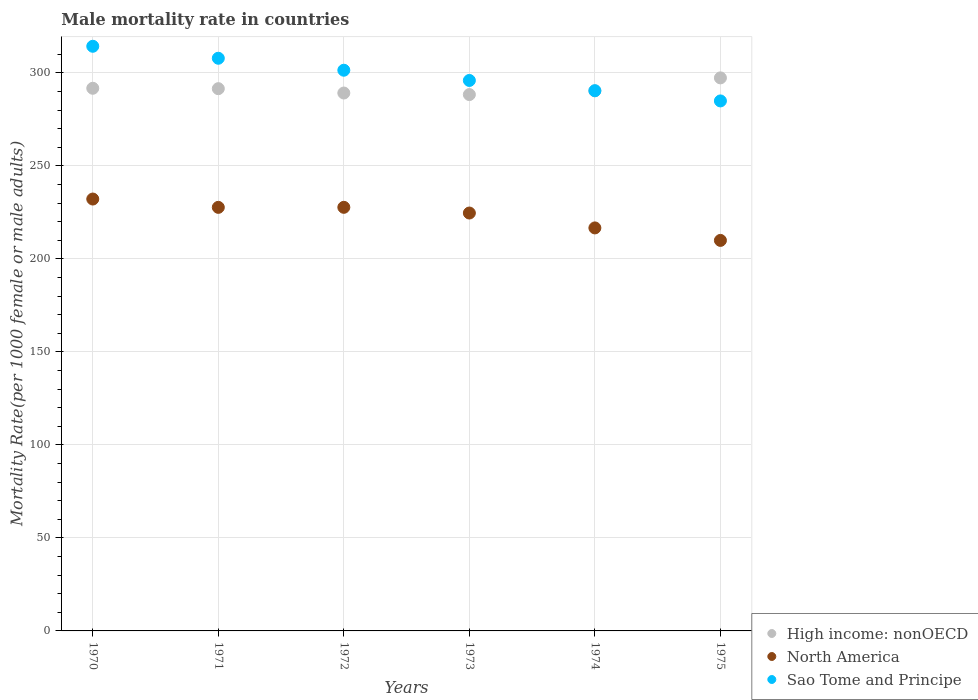How many different coloured dotlines are there?
Make the answer very short. 3. Is the number of dotlines equal to the number of legend labels?
Provide a succinct answer. Yes. What is the male mortality rate in Sao Tome and Principe in 1971?
Keep it short and to the point. 307.91. Across all years, what is the maximum male mortality rate in North America?
Your answer should be very brief. 232.21. Across all years, what is the minimum male mortality rate in Sao Tome and Principe?
Offer a very short reply. 284.97. In which year was the male mortality rate in High income: nonOECD maximum?
Your answer should be very brief. 1975. In which year was the male mortality rate in Sao Tome and Principe minimum?
Offer a terse response. 1975. What is the total male mortality rate in High income: nonOECD in the graph?
Ensure brevity in your answer.  1748.66. What is the difference between the male mortality rate in Sao Tome and Principe in 1972 and that in 1973?
Make the answer very short. 5.5. What is the difference between the male mortality rate in Sao Tome and Principe in 1971 and the male mortality rate in High income: nonOECD in 1974?
Give a very brief answer. 17.53. What is the average male mortality rate in Sao Tome and Principe per year?
Ensure brevity in your answer.  299.19. In the year 1970, what is the difference between the male mortality rate in Sao Tome and Principe and male mortality rate in High income: nonOECD?
Make the answer very short. 22.58. In how many years, is the male mortality rate in Sao Tome and Principe greater than 280?
Offer a terse response. 6. What is the ratio of the male mortality rate in North America in 1970 to that in 1971?
Provide a short and direct response. 1.02. Is the male mortality rate in High income: nonOECD in 1970 less than that in 1975?
Your answer should be compact. Yes. What is the difference between the highest and the second highest male mortality rate in High income: nonOECD?
Offer a terse response. 5.59. What is the difference between the highest and the lowest male mortality rate in North America?
Ensure brevity in your answer.  22.24. In how many years, is the male mortality rate in North America greater than the average male mortality rate in North America taken over all years?
Your answer should be compact. 4. Is the sum of the male mortality rate in High income: nonOECD in 1971 and 1974 greater than the maximum male mortality rate in North America across all years?
Your answer should be very brief. Yes. Does the male mortality rate in High income: nonOECD monotonically increase over the years?
Offer a terse response. No. Is the male mortality rate in High income: nonOECD strictly less than the male mortality rate in Sao Tome and Principe over the years?
Give a very brief answer. No. Does the graph contain grids?
Your response must be concise. Yes. How many legend labels are there?
Offer a terse response. 3. What is the title of the graph?
Your answer should be compact. Male mortality rate in countries. What is the label or title of the X-axis?
Offer a terse response. Years. What is the label or title of the Y-axis?
Keep it short and to the point. Mortality Rate(per 1000 female or male adults). What is the Mortality Rate(per 1000 female or male adults) of High income: nonOECD in 1970?
Your answer should be very brief. 291.77. What is the Mortality Rate(per 1000 female or male adults) in North America in 1970?
Offer a terse response. 232.21. What is the Mortality Rate(per 1000 female or male adults) in Sao Tome and Principe in 1970?
Your answer should be compact. 314.35. What is the Mortality Rate(per 1000 female or male adults) of High income: nonOECD in 1971?
Provide a succinct answer. 291.56. What is the Mortality Rate(per 1000 female or male adults) in North America in 1971?
Offer a terse response. 227.74. What is the Mortality Rate(per 1000 female or male adults) of Sao Tome and Principe in 1971?
Your answer should be very brief. 307.91. What is the Mortality Rate(per 1000 female or male adults) in High income: nonOECD in 1972?
Offer a terse response. 289.22. What is the Mortality Rate(per 1000 female or male adults) in North America in 1972?
Ensure brevity in your answer.  227.76. What is the Mortality Rate(per 1000 female or male adults) in Sao Tome and Principe in 1972?
Make the answer very short. 301.48. What is the Mortality Rate(per 1000 female or male adults) in High income: nonOECD in 1973?
Provide a succinct answer. 288.38. What is the Mortality Rate(per 1000 female or male adults) in North America in 1973?
Your answer should be very brief. 224.69. What is the Mortality Rate(per 1000 female or male adults) of Sao Tome and Principe in 1973?
Give a very brief answer. 295.97. What is the Mortality Rate(per 1000 female or male adults) in High income: nonOECD in 1974?
Offer a terse response. 290.38. What is the Mortality Rate(per 1000 female or male adults) of North America in 1974?
Your response must be concise. 216.69. What is the Mortality Rate(per 1000 female or male adults) of Sao Tome and Principe in 1974?
Keep it short and to the point. 290.47. What is the Mortality Rate(per 1000 female or male adults) in High income: nonOECD in 1975?
Keep it short and to the point. 297.35. What is the Mortality Rate(per 1000 female or male adults) of North America in 1975?
Make the answer very short. 209.97. What is the Mortality Rate(per 1000 female or male adults) in Sao Tome and Principe in 1975?
Ensure brevity in your answer.  284.97. Across all years, what is the maximum Mortality Rate(per 1000 female or male adults) of High income: nonOECD?
Provide a short and direct response. 297.35. Across all years, what is the maximum Mortality Rate(per 1000 female or male adults) of North America?
Keep it short and to the point. 232.21. Across all years, what is the maximum Mortality Rate(per 1000 female or male adults) in Sao Tome and Principe?
Make the answer very short. 314.35. Across all years, what is the minimum Mortality Rate(per 1000 female or male adults) of High income: nonOECD?
Keep it short and to the point. 288.38. Across all years, what is the minimum Mortality Rate(per 1000 female or male adults) in North America?
Keep it short and to the point. 209.97. Across all years, what is the minimum Mortality Rate(per 1000 female or male adults) of Sao Tome and Principe?
Provide a short and direct response. 284.97. What is the total Mortality Rate(per 1000 female or male adults) in High income: nonOECD in the graph?
Provide a short and direct response. 1748.66. What is the total Mortality Rate(per 1000 female or male adults) in North America in the graph?
Your answer should be very brief. 1339.06. What is the total Mortality Rate(per 1000 female or male adults) of Sao Tome and Principe in the graph?
Your answer should be very brief. 1795.14. What is the difference between the Mortality Rate(per 1000 female or male adults) of High income: nonOECD in 1970 and that in 1971?
Provide a short and direct response. 0.21. What is the difference between the Mortality Rate(per 1000 female or male adults) in North America in 1970 and that in 1971?
Provide a short and direct response. 4.47. What is the difference between the Mortality Rate(per 1000 female or male adults) in Sao Tome and Principe in 1970 and that in 1971?
Your answer should be very brief. 6.44. What is the difference between the Mortality Rate(per 1000 female or male adults) of High income: nonOECD in 1970 and that in 1972?
Keep it short and to the point. 2.55. What is the difference between the Mortality Rate(per 1000 female or male adults) of North America in 1970 and that in 1972?
Give a very brief answer. 4.46. What is the difference between the Mortality Rate(per 1000 female or male adults) of Sao Tome and Principe in 1970 and that in 1972?
Give a very brief answer. 12.87. What is the difference between the Mortality Rate(per 1000 female or male adults) in High income: nonOECD in 1970 and that in 1973?
Your answer should be compact. 3.38. What is the difference between the Mortality Rate(per 1000 female or male adults) in North America in 1970 and that in 1973?
Give a very brief answer. 7.52. What is the difference between the Mortality Rate(per 1000 female or male adults) of Sao Tome and Principe in 1970 and that in 1973?
Offer a very short reply. 18.38. What is the difference between the Mortality Rate(per 1000 female or male adults) of High income: nonOECD in 1970 and that in 1974?
Your answer should be very brief. 1.38. What is the difference between the Mortality Rate(per 1000 female or male adults) of North America in 1970 and that in 1974?
Keep it short and to the point. 15.53. What is the difference between the Mortality Rate(per 1000 female or male adults) of Sao Tome and Principe in 1970 and that in 1974?
Offer a terse response. 23.88. What is the difference between the Mortality Rate(per 1000 female or male adults) of High income: nonOECD in 1970 and that in 1975?
Offer a terse response. -5.59. What is the difference between the Mortality Rate(per 1000 female or male adults) of North America in 1970 and that in 1975?
Your response must be concise. 22.24. What is the difference between the Mortality Rate(per 1000 female or male adults) in Sao Tome and Principe in 1970 and that in 1975?
Provide a succinct answer. 29.38. What is the difference between the Mortality Rate(per 1000 female or male adults) of High income: nonOECD in 1971 and that in 1972?
Offer a terse response. 2.34. What is the difference between the Mortality Rate(per 1000 female or male adults) in North America in 1971 and that in 1972?
Your answer should be very brief. -0.02. What is the difference between the Mortality Rate(per 1000 female or male adults) in Sao Tome and Principe in 1971 and that in 1972?
Provide a short and direct response. 6.44. What is the difference between the Mortality Rate(per 1000 female or male adults) in High income: nonOECD in 1971 and that in 1973?
Provide a succinct answer. 3.17. What is the difference between the Mortality Rate(per 1000 female or male adults) of North America in 1971 and that in 1973?
Offer a terse response. 3.05. What is the difference between the Mortality Rate(per 1000 female or male adults) in Sao Tome and Principe in 1971 and that in 1973?
Ensure brevity in your answer.  11.94. What is the difference between the Mortality Rate(per 1000 female or male adults) of High income: nonOECD in 1971 and that in 1974?
Your answer should be very brief. 1.17. What is the difference between the Mortality Rate(per 1000 female or male adults) in North America in 1971 and that in 1974?
Your answer should be very brief. 11.05. What is the difference between the Mortality Rate(per 1000 female or male adults) of Sao Tome and Principe in 1971 and that in 1974?
Your answer should be compact. 17.44. What is the difference between the Mortality Rate(per 1000 female or male adults) of High income: nonOECD in 1971 and that in 1975?
Keep it short and to the point. -5.8. What is the difference between the Mortality Rate(per 1000 female or male adults) of North America in 1971 and that in 1975?
Ensure brevity in your answer.  17.77. What is the difference between the Mortality Rate(per 1000 female or male adults) in Sao Tome and Principe in 1971 and that in 1975?
Your answer should be compact. 22.95. What is the difference between the Mortality Rate(per 1000 female or male adults) of High income: nonOECD in 1972 and that in 1973?
Your answer should be compact. 0.83. What is the difference between the Mortality Rate(per 1000 female or male adults) of North America in 1972 and that in 1973?
Provide a succinct answer. 3.07. What is the difference between the Mortality Rate(per 1000 female or male adults) in Sao Tome and Principe in 1972 and that in 1973?
Provide a succinct answer. 5.5. What is the difference between the Mortality Rate(per 1000 female or male adults) of High income: nonOECD in 1972 and that in 1974?
Your response must be concise. -1.17. What is the difference between the Mortality Rate(per 1000 female or male adults) in North America in 1972 and that in 1974?
Give a very brief answer. 11.07. What is the difference between the Mortality Rate(per 1000 female or male adults) of Sao Tome and Principe in 1972 and that in 1974?
Your answer should be very brief. 11.01. What is the difference between the Mortality Rate(per 1000 female or male adults) in High income: nonOECD in 1972 and that in 1975?
Make the answer very short. -8.14. What is the difference between the Mortality Rate(per 1000 female or male adults) in North America in 1972 and that in 1975?
Provide a short and direct response. 17.79. What is the difference between the Mortality Rate(per 1000 female or male adults) of Sao Tome and Principe in 1972 and that in 1975?
Provide a short and direct response. 16.51. What is the difference between the Mortality Rate(per 1000 female or male adults) in High income: nonOECD in 1973 and that in 1974?
Your answer should be very brief. -2. What is the difference between the Mortality Rate(per 1000 female or male adults) of North America in 1973 and that in 1974?
Make the answer very short. 8.01. What is the difference between the Mortality Rate(per 1000 female or male adults) in Sao Tome and Principe in 1973 and that in 1974?
Provide a short and direct response. 5.5. What is the difference between the Mortality Rate(per 1000 female or male adults) in High income: nonOECD in 1973 and that in 1975?
Your answer should be very brief. -8.97. What is the difference between the Mortality Rate(per 1000 female or male adults) in North America in 1973 and that in 1975?
Your answer should be very brief. 14.72. What is the difference between the Mortality Rate(per 1000 female or male adults) in Sao Tome and Principe in 1973 and that in 1975?
Your response must be concise. 11.01. What is the difference between the Mortality Rate(per 1000 female or male adults) in High income: nonOECD in 1974 and that in 1975?
Your answer should be compact. -6.97. What is the difference between the Mortality Rate(per 1000 female or male adults) of North America in 1974 and that in 1975?
Give a very brief answer. 6.71. What is the difference between the Mortality Rate(per 1000 female or male adults) in Sao Tome and Principe in 1974 and that in 1975?
Keep it short and to the point. 5.5. What is the difference between the Mortality Rate(per 1000 female or male adults) in High income: nonOECD in 1970 and the Mortality Rate(per 1000 female or male adults) in North America in 1971?
Keep it short and to the point. 64.03. What is the difference between the Mortality Rate(per 1000 female or male adults) of High income: nonOECD in 1970 and the Mortality Rate(per 1000 female or male adults) of Sao Tome and Principe in 1971?
Offer a terse response. -16.14. What is the difference between the Mortality Rate(per 1000 female or male adults) in North America in 1970 and the Mortality Rate(per 1000 female or male adults) in Sao Tome and Principe in 1971?
Your answer should be compact. -75.7. What is the difference between the Mortality Rate(per 1000 female or male adults) in High income: nonOECD in 1970 and the Mortality Rate(per 1000 female or male adults) in North America in 1972?
Offer a terse response. 64.01. What is the difference between the Mortality Rate(per 1000 female or male adults) of High income: nonOECD in 1970 and the Mortality Rate(per 1000 female or male adults) of Sao Tome and Principe in 1972?
Make the answer very short. -9.71. What is the difference between the Mortality Rate(per 1000 female or male adults) in North America in 1970 and the Mortality Rate(per 1000 female or male adults) in Sao Tome and Principe in 1972?
Ensure brevity in your answer.  -69.26. What is the difference between the Mortality Rate(per 1000 female or male adults) in High income: nonOECD in 1970 and the Mortality Rate(per 1000 female or male adults) in North America in 1973?
Provide a short and direct response. 67.08. What is the difference between the Mortality Rate(per 1000 female or male adults) of High income: nonOECD in 1970 and the Mortality Rate(per 1000 female or male adults) of Sao Tome and Principe in 1973?
Offer a very short reply. -4.21. What is the difference between the Mortality Rate(per 1000 female or male adults) of North America in 1970 and the Mortality Rate(per 1000 female or male adults) of Sao Tome and Principe in 1973?
Provide a short and direct response. -63.76. What is the difference between the Mortality Rate(per 1000 female or male adults) of High income: nonOECD in 1970 and the Mortality Rate(per 1000 female or male adults) of North America in 1974?
Keep it short and to the point. 75.08. What is the difference between the Mortality Rate(per 1000 female or male adults) of High income: nonOECD in 1970 and the Mortality Rate(per 1000 female or male adults) of Sao Tome and Principe in 1974?
Offer a very short reply. 1.3. What is the difference between the Mortality Rate(per 1000 female or male adults) of North America in 1970 and the Mortality Rate(per 1000 female or male adults) of Sao Tome and Principe in 1974?
Offer a very short reply. -58.25. What is the difference between the Mortality Rate(per 1000 female or male adults) of High income: nonOECD in 1970 and the Mortality Rate(per 1000 female or male adults) of North America in 1975?
Provide a succinct answer. 81.79. What is the difference between the Mortality Rate(per 1000 female or male adults) of High income: nonOECD in 1970 and the Mortality Rate(per 1000 female or male adults) of Sao Tome and Principe in 1975?
Your answer should be compact. 6.8. What is the difference between the Mortality Rate(per 1000 female or male adults) in North America in 1970 and the Mortality Rate(per 1000 female or male adults) in Sao Tome and Principe in 1975?
Offer a terse response. -52.75. What is the difference between the Mortality Rate(per 1000 female or male adults) in High income: nonOECD in 1971 and the Mortality Rate(per 1000 female or male adults) in North America in 1972?
Provide a short and direct response. 63.8. What is the difference between the Mortality Rate(per 1000 female or male adults) of High income: nonOECD in 1971 and the Mortality Rate(per 1000 female or male adults) of Sao Tome and Principe in 1972?
Provide a short and direct response. -9.92. What is the difference between the Mortality Rate(per 1000 female or male adults) of North America in 1971 and the Mortality Rate(per 1000 female or male adults) of Sao Tome and Principe in 1972?
Provide a succinct answer. -73.74. What is the difference between the Mortality Rate(per 1000 female or male adults) in High income: nonOECD in 1971 and the Mortality Rate(per 1000 female or male adults) in North America in 1973?
Offer a very short reply. 66.87. What is the difference between the Mortality Rate(per 1000 female or male adults) of High income: nonOECD in 1971 and the Mortality Rate(per 1000 female or male adults) of Sao Tome and Principe in 1973?
Offer a terse response. -4.41. What is the difference between the Mortality Rate(per 1000 female or male adults) in North America in 1971 and the Mortality Rate(per 1000 female or male adults) in Sao Tome and Principe in 1973?
Provide a short and direct response. -68.23. What is the difference between the Mortality Rate(per 1000 female or male adults) in High income: nonOECD in 1971 and the Mortality Rate(per 1000 female or male adults) in North America in 1974?
Keep it short and to the point. 74.87. What is the difference between the Mortality Rate(per 1000 female or male adults) of High income: nonOECD in 1971 and the Mortality Rate(per 1000 female or male adults) of Sao Tome and Principe in 1974?
Make the answer very short. 1.09. What is the difference between the Mortality Rate(per 1000 female or male adults) in North America in 1971 and the Mortality Rate(per 1000 female or male adults) in Sao Tome and Principe in 1974?
Give a very brief answer. -62.73. What is the difference between the Mortality Rate(per 1000 female or male adults) of High income: nonOECD in 1971 and the Mortality Rate(per 1000 female or male adults) of North America in 1975?
Keep it short and to the point. 81.58. What is the difference between the Mortality Rate(per 1000 female or male adults) in High income: nonOECD in 1971 and the Mortality Rate(per 1000 female or male adults) in Sao Tome and Principe in 1975?
Give a very brief answer. 6.59. What is the difference between the Mortality Rate(per 1000 female or male adults) of North America in 1971 and the Mortality Rate(per 1000 female or male adults) of Sao Tome and Principe in 1975?
Offer a very short reply. -57.23. What is the difference between the Mortality Rate(per 1000 female or male adults) in High income: nonOECD in 1972 and the Mortality Rate(per 1000 female or male adults) in North America in 1973?
Keep it short and to the point. 64.53. What is the difference between the Mortality Rate(per 1000 female or male adults) of High income: nonOECD in 1972 and the Mortality Rate(per 1000 female or male adults) of Sao Tome and Principe in 1973?
Your answer should be compact. -6.76. What is the difference between the Mortality Rate(per 1000 female or male adults) of North America in 1972 and the Mortality Rate(per 1000 female or male adults) of Sao Tome and Principe in 1973?
Your response must be concise. -68.21. What is the difference between the Mortality Rate(per 1000 female or male adults) of High income: nonOECD in 1972 and the Mortality Rate(per 1000 female or male adults) of North America in 1974?
Ensure brevity in your answer.  72.53. What is the difference between the Mortality Rate(per 1000 female or male adults) of High income: nonOECD in 1972 and the Mortality Rate(per 1000 female or male adults) of Sao Tome and Principe in 1974?
Provide a succinct answer. -1.25. What is the difference between the Mortality Rate(per 1000 female or male adults) of North America in 1972 and the Mortality Rate(per 1000 female or male adults) of Sao Tome and Principe in 1974?
Make the answer very short. -62.71. What is the difference between the Mortality Rate(per 1000 female or male adults) of High income: nonOECD in 1972 and the Mortality Rate(per 1000 female or male adults) of North America in 1975?
Your response must be concise. 79.24. What is the difference between the Mortality Rate(per 1000 female or male adults) in High income: nonOECD in 1972 and the Mortality Rate(per 1000 female or male adults) in Sao Tome and Principe in 1975?
Make the answer very short. 4.25. What is the difference between the Mortality Rate(per 1000 female or male adults) in North America in 1972 and the Mortality Rate(per 1000 female or male adults) in Sao Tome and Principe in 1975?
Offer a terse response. -57.21. What is the difference between the Mortality Rate(per 1000 female or male adults) of High income: nonOECD in 1973 and the Mortality Rate(per 1000 female or male adults) of North America in 1974?
Your response must be concise. 71.7. What is the difference between the Mortality Rate(per 1000 female or male adults) of High income: nonOECD in 1973 and the Mortality Rate(per 1000 female or male adults) of Sao Tome and Principe in 1974?
Provide a succinct answer. -2.09. What is the difference between the Mortality Rate(per 1000 female or male adults) in North America in 1973 and the Mortality Rate(per 1000 female or male adults) in Sao Tome and Principe in 1974?
Offer a terse response. -65.78. What is the difference between the Mortality Rate(per 1000 female or male adults) in High income: nonOECD in 1973 and the Mortality Rate(per 1000 female or male adults) in North America in 1975?
Provide a short and direct response. 78.41. What is the difference between the Mortality Rate(per 1000 female or male adults) of High income: nonOECD in 1973 and the Mortality Rate(per 1000 female or male adults) of Sao Tome and Principe in 1975?
Ensure brevity in your answer.  3.42. What is the difference between the Mortality Rate(per 1000 female or male adults) of North America in 1973 and the Mortality Rate(per 1000 female or male adults) of Sao Tome and Principe in 1975?
Keep it short and to the point. -60.28. What is the difference between the Mortality Rate(per 1000 female or male adults) of High income: nonOECD in 1974 and the Mortality Rate(per 1000 female or male adults) of North America in 1975?
Offer a terse response. 80.41. What is the difference between the Mortality Rate(per 1000 female or male adults) in High income: nonOECD in 1974 and the Mortality Rate(per 1000 female or male adults) in Sao Tome and Principe in 1975?
Offer a terse response. 5.42. What is the difference between the Mortality Rate(per 1000 female or male adults) in North America in 1974 and the Mortality Rate(per 1000 female or male adults) in Sao Tome and Principe in 1975?
Offer a very short reply. -68.28. What is the average Mortality Rate(per 1000 female or male adults) of High income: nonOECD per year?
Ensure brevity in your answer.  291.44. What is the average Mortality Rate(per 1000 female or male adults) in North America per year?
Keep it short and to the point. 223.18. What is the average Mortality Rate(per 1000 female or male adults) of Sao Tome and Principe per year?
Provide a short and direct response. 299.19. In the year 1970, what is the difference between the Mortality Rate(per 1000 female or male adults) of High income: nonOECD and Mortality Rate(per 1000 female or male adults) of North America?
Your response must be concise. 59.55. In the year 1970, what is the difference between the Mortality Rate(per 1000 female or male adults) of High income: nonOECD and Mortality Rate(per 1000 female or male adults) of Sao Tome and Principe?
Provide a short and direct response. -22.58. In the year 1970, what is the difference between the Mortality Rate(per 1000 female or male adults) of North America and Mortality Rate(per 1000 female or male adults) of Sao Tome and Principe?
Your response must be concise. -82.13. In the year 1971, what is the difference between the Mortality Rate(per 1000 female or male adults) in High income: nonOECD and Mortality Rate(per 1000 female or male adults) in North America?
Give a very brief answer. 63.82. In the year 1971, what is the difference between the Mortality Rate(per 1000 female or male adults) in High income: nonOECD and Mortality Rate(per 1000 female or male adults) in Sao Tome and Principe?
Offer a very short reply. -16.35. In the year 1971, what is the difference between the Mortality Rate(per 1000 female or male adults) of North America and Mortality Rate(per 1000 female or male adults) of Sao Tome and Principe?
Offer a terse response. -80.17. In the year 1972, what is the difference between the Mortality Rate(per 1000 female or male adults) of High income: nonOECD and Mortality Rate(per 1000 female or male adults) of North America?
Your answer should be compact. 61.46. In the year 1972, what is the difference between the Mortality Rate(per 1000 female or male adults) of High income: nonOECD and Mortality Rate(per 1000 female or male adults) of Sao Tome and Principe?
Give a very brief answer. -12.26. In the year 1972, what is the difference between the Mortality Rate(per 1000 female or male adults) in North America and Mortality Rate(per 1000 female or male adults) in Sao Tome and Principe?
Provide a short and direct response. -73.72. In the year 1973, what is the difference between the Mortality Rate(per 1000 female or male adults) of High income: nonOECD and Mortality Rate(per 1000 female or male adults) of North America?
Give a very brief answer. 63.69. In the year 1973, what is the difference between the Mortality Rate(per 1000 female or male adults) of High income: nonOECD and Mortality Rate(per 1000 female or male adults) of Sao Tome and Principe?
Keep it short and to the point. -7.59. In the year 1973, what is the difference between the Mortality Rate(per 1000 female or male adults) of North America and Mortality Rate(per 1000 female or male adults) of Sao Tome and Principe?
Offer a very short reply. -71.28. In the year 1974, what is the difference between the Mortality Rate(per 1000 female or male adults) of High income: nonOECD and Mortality Rate(per 1000 female or male adults) of North America?
Ensure brevity in your answer.  73.7. In the year 1974, what is the difference between the Mortality Rate(per 1000 female or male adults) in High income: nonOECD and Mortality Rate(per 1000 female or male adults) in Sao Tome and Principe?
Your response must be concise. -0.09. In the year 1974, what is the difference between the Mortality Rate(per 1000 female or male adults) of North America and Mortality Rate(per 1000 female or male adults) of Sao Tome and Principe?
Provide a short and direct response. -73.78. In the year 1975, what is the difference between the Mortality Rate(per 1000 female or male adults) of High income: nonOECD and Mortality Rate(per 1000 female or male adults) of North America?
Provide a short and direct response. 87.38. In the year 1975, what is the difference between the Mortality Rate(per 1000 female or male adults) in High income: nonOECD and Mortality Rate(per 1000 female or male adults) in Sao Tome and Principe?
Offer a very short reply. 12.39. In the year 1975, what is the difference between the Mortality Rate(per 1000 female or male adults) of North America and Mortality Rate(per 1000 female or male adults) of Sao Tome and Principe?
Provide a short and direct response. -74.99. What is the ratio of the Mortality Rate(per 1000 female or male adults) of North America in 1970 to that in 1971?
Your answer should be compact. 1.02. What is the ratio of the Mortality Rate(per 1000 female or male adults) of Sao Tome and Principe in 1970 to that in 1971?
Your answer should be compact. 1.02. What is the ratio of the Mortality Rate(per 1000 female or male adults) in High income: nonOECD in 1970 to that in 1972?
Your answer should be very brief. 1.01. What is the ratio of the Mortality Rate(per 1000 female or male adults) of North America in 1970 to that in 1972?
Your answer should be very brief. 1.02. What is the ratio of the Mortality Rate(per 1000 female or male adults) in Sao Tome and Principe in 1970 to that in 1972?
Provide a short and direct response. 1.04. What is the ratio of the Mortality Rate(per 1000 female or male adults) of High income: nonOECD in 1970 to that in 1973?
Ensure brevity in your answer.  1.01. What is the ratio of the Mortality Rate(per 1000 female or male adults) of North America in 1970 to that in 1973?
Your answer should be compact. 1.03. What is the ratio of the Mortality Rate(per 1000 female or male adults) of Sao Tome and Principe in 1970 to that in 1973?
Offer a terse response. 1.06. What is the ratio of the Mortality Rate(per 1000 female or male adults) of High income: nonOECD in 1970 to that in 1974?
Provide a succinct answer. 1. What is the ratio of the Mortality Rate(per 1000 female or male adults) in North America in 1970 to that in 1974?
Provide a short and direct response. 1.07. What is the ratio of the Mortality Rate(per 1000 female or male adults) of Sao Tome and Principe in 1970 to that in 1974?
Give a very brief answer. 1.08. What is the ratio of the Mortality Rate(per 1000 female or male adults) of High income: nonOECD in 1970 to that in 1975?
Ensure brevity in your answer.  0.98. What is the ratio of the Mortality Rate(per 1000 female or male adults) of North America in 1970 to that in 1975?
Keep it short and to the point. 1.11. What is the ratio of the Mortality Rate(per 1000 female or male adults) of Sao Tome and Principe in 1970 to that in 1975?
Your answer should be compact. 1.1. What is the ratio of the Mortality Rate(per 1000 female or male adults) of Sao Tome and Principe in 1971 to that in 1972?
Ensure brevity in your answer.  1.02. What is the ratio of the Mortality Rate(per 1000 female or male adults) in North America in 1971 to that in 1973?
Offer a terse response. 1.01. What is the ratio of the Mortality Rate(per 1000 female or male adults) of Sao Tome and Principe in 1971 to that in 1973?
Ensure brevity in your answer.  1.04. What is the ratio of the Mortality Rate(per 1000 female or male adults) in High income: nonOECD in 1971 to that in 1974?
Your answer should be compact. 1. What is the ratio of the Mortality Rate(per 1000 female or male adults) of North America in 1971 to that in 1974?
Make the answer very short. 1.05. What is the ratio of the Mortality Rate(per 1000 female or male adults) of Sao Tome and Principe in 1971 to that in 1974?
Provide a succinct answer. 1.06. What is the ratio of the Mortality Rate(per 1000 female or male adults) of High income: nonOECD in 1971 to that in 1975?
Offer a very short reply. 0.98. What is the ratio of the Mortality Rate(per 1000 female or male adults) in North America in 1971 to that in 1975?
Give a very brief answer. 1.08. What is the ratio of the Mortality Rate(per 1000 female or male adults) of Sao Tome and Principe in 1971 to that in 1975?
Your response must be concise. 1.08. What is the ratio of the Mortality Rate(per 1000 female or male adults) of North America in 1972 to that in 1973?
Offer a very short reply. 1.01. What is the ratio of the Mortality Rate(per 1000 female or male adults) in Sao Tome and Principe in 1972 to that in 1973?
Give a very brief answer. 1.02. What is the ratio of the Mortality Rate(per 1000 female or male adults) of North America in 1972 to that in 1974?
Offer a very short reply. 1.05. What is the ratio of the Mortality Rate(per 1000 female or male adults) in Sao Tome and Principe in 1972 to that in 1974?
Ensure brevity in your answer.  1.04. What is the ratio of the Mortality Rate(per 1000 female or male adults) of High income: nonOECD in 1972 to that in 1975?
Make the answer very short. 0.97. What is the ratio of the Mortality Rate(per 1000 female or male adults) in North America in 1972 to that in 1975?
Your answer should be compact. 1.08. What is the ratio of the Mortality Rate(per 1000 female or male adults) of Sao Tome and Principe in 1972 to that in 1975?
Provide a short and direct response. 1.06. What is the ratio of the Mortality Rate(per 1000 female or male adults) of High income: nonOECD in 1973 to that in 1974?
Provide a short and direct response. 0.99. What is the ratio of the Mortality Rate(per 1000 female or male adults) of North America in 1973 to that in 1974?
Your answer should be compact. 1.04. What is the ratio of the Mortality Rate(per 1000 female or male adults) in Sao Tome and Principe in 1973 to that in 1974?
Make the answer very short. 1.02. What is the ratio of the Mortality Rate(per 1000 female or male adults) of High income: nonOECD in 1973 to that in 1975?
Your answer should be very brief. 0.97. What is the ratio of the Mortality Rate(per 1000 female or male adults) in North America in 1973 to that in 1975?
Ensure brevity in your answer.  1.07. What is the ratio of the Mortality Rate(per 1000 female or male adults) of Sao Tome and Principe in 1973 to that in 1975?
Provide a succinct answer. 1.04. What is the ratio of the Mortality Rate(per 1000 female or male adults) of High income: nonOECD in 1974 to that in 1975?
Offer a very short reply. 0.98. What is the ratio of the Mortality Rate(per 1000 female or male adults) in North America in 1974 to that in 1975?
Provide a succinct answer. 1.03. What is the ratio of the Mortality Rate(per 1000 female or male adults) in Sao Tome and Principe in 1974 to that in 1975?
Offer a terse response. 1.02. What is the difference between the highest and the second highest Mortality Rate(per 1000 female or male adults) in High income: nonOECD?
Offer a very short reply. 5.59. What is the difference between the highest and the second highest Mortality Rate(per 1000 female or male adults) in North America?
Your answer should be compact. 4.46. What is the difference between the highest and the second highest Mortality Rate(per 1000 female or male adults) in Sao Tome and Principe?
Keep it short and to the point. 6.44. What is the difference between the highest and the lowest Mortality Rate(per 1000 female or male adults) of High income: nonOECD?
Make the answer very short. 8.97. What is the difference between the highest and the lowest Mortality Rate(per 1000 female or male adults) of North America?
Give a very brief answer. 22.24. What is the difference between the highest and the lowest Mortality Rate(per 1000 female or male adults) of Sao Tome and Principe?
Make the answer very short. 29.38. 